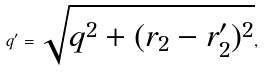Convert formula to latex. <formula><loc_0><loc_0><loc_500><loc_500>q ^ { \prime } = \sqrt { q ^ { 2 } + ( r _ { 2 } - r _ { 2 } ^ { \prime } ) ^ { 2 } } ,</formula> 